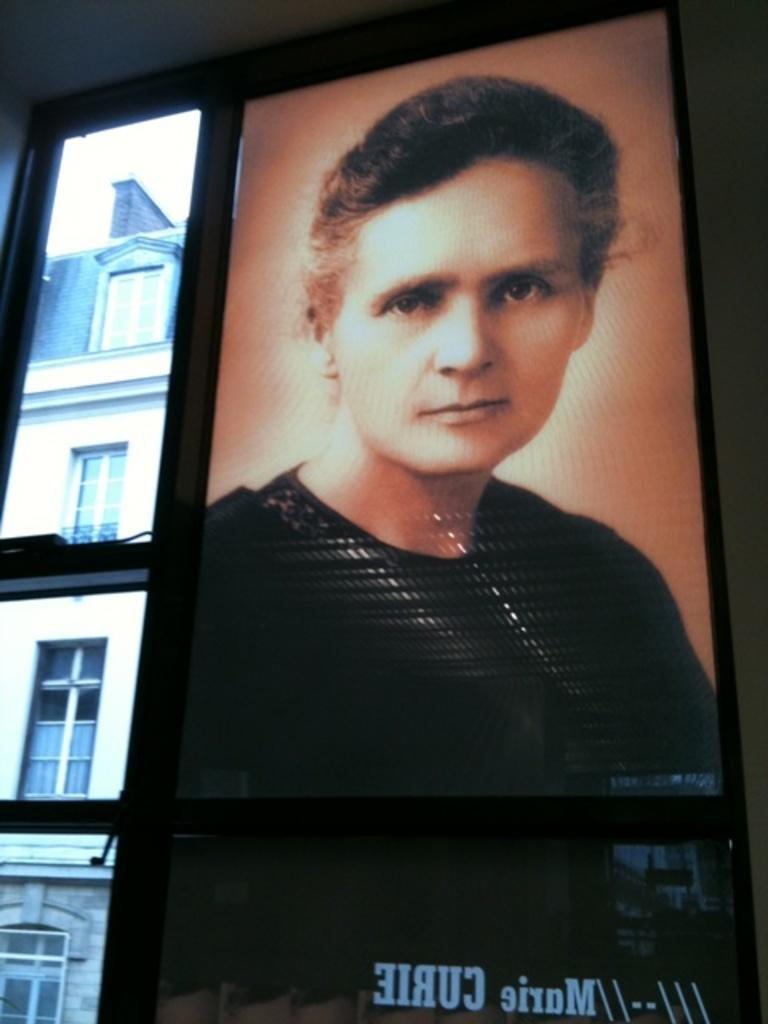What is placed on the window in the image? There is a poster on the window. What can be seen in the background of the image? There is a building visible in the background. What type of invention can be seen in the image? There is no invention present in the image; it features a poster on the window and a building in the background. Can you tell me how many giraffes are visible in the image? There are no giraffes present in the image. 